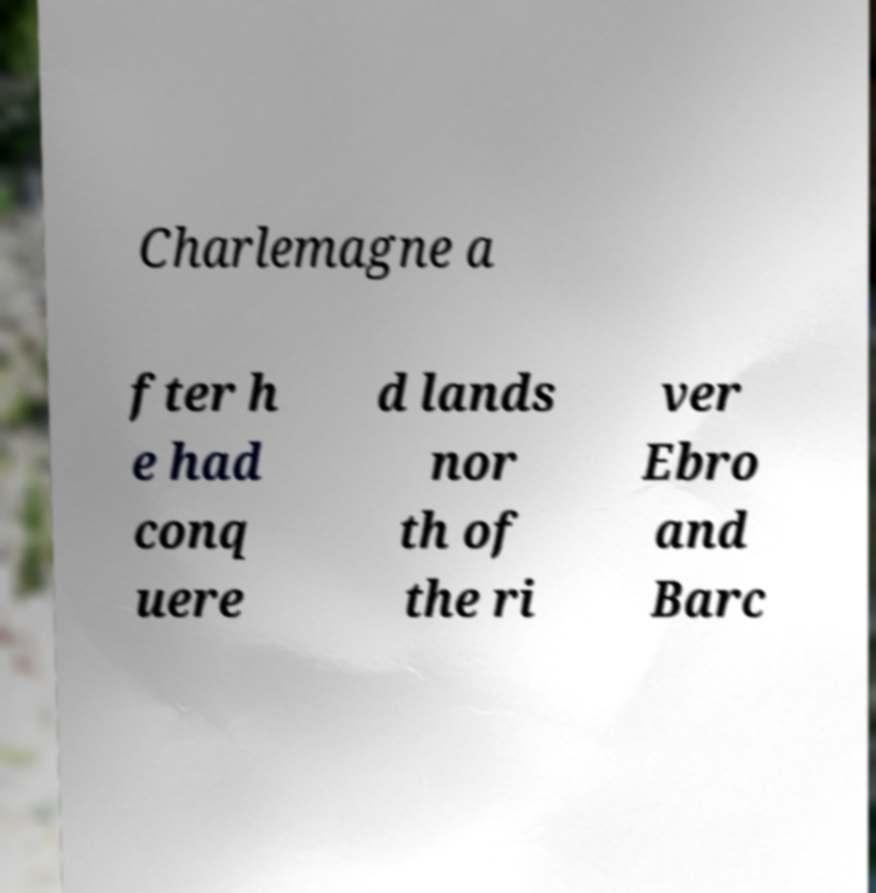Please identify and transcribe the text found in this image. Charlemagne a fter h e had conq uere d lands nor th of the ri ver Ebro and Barc 